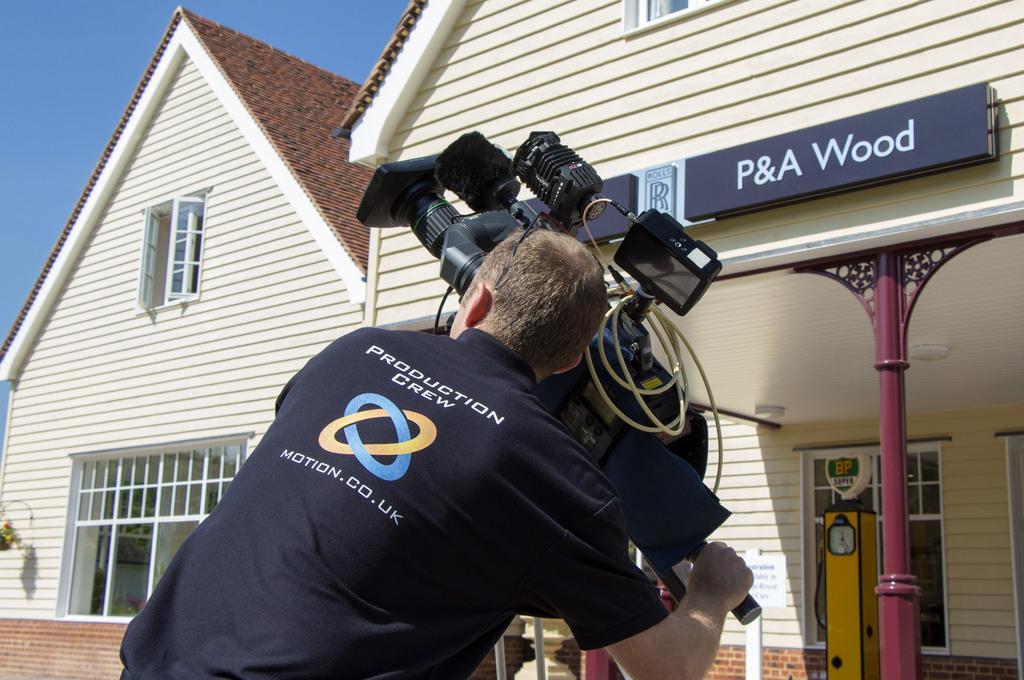Could you give a brief overview of what you see in this image? In this picture there is a man in the center holding a camera. In the background there is a building and on the wall of the building there is a board with some text written on it. 